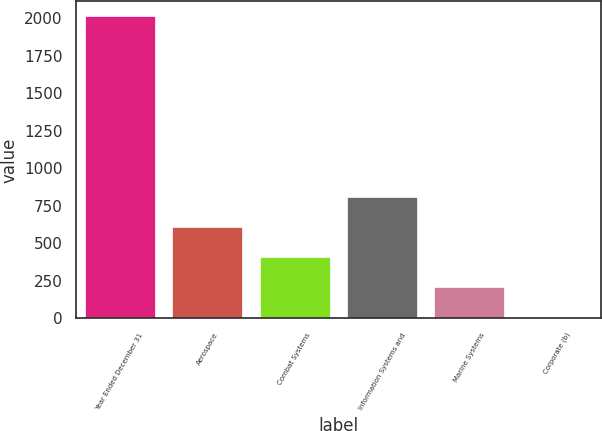<chart> <loc_0><loc_0><loc_500><loc_500><bar_chart><fcel>Year Ended December 31<fcel>Aerospace<fcel>Combat Systems<fcel>Information Systems and<fcel>Marine Systems<fcel>Corporate (b)<nl><fcel>2013<fcel>609.5<fcel>409<fcel>810<fcel>208.5<fcel>8<nl></chart> 